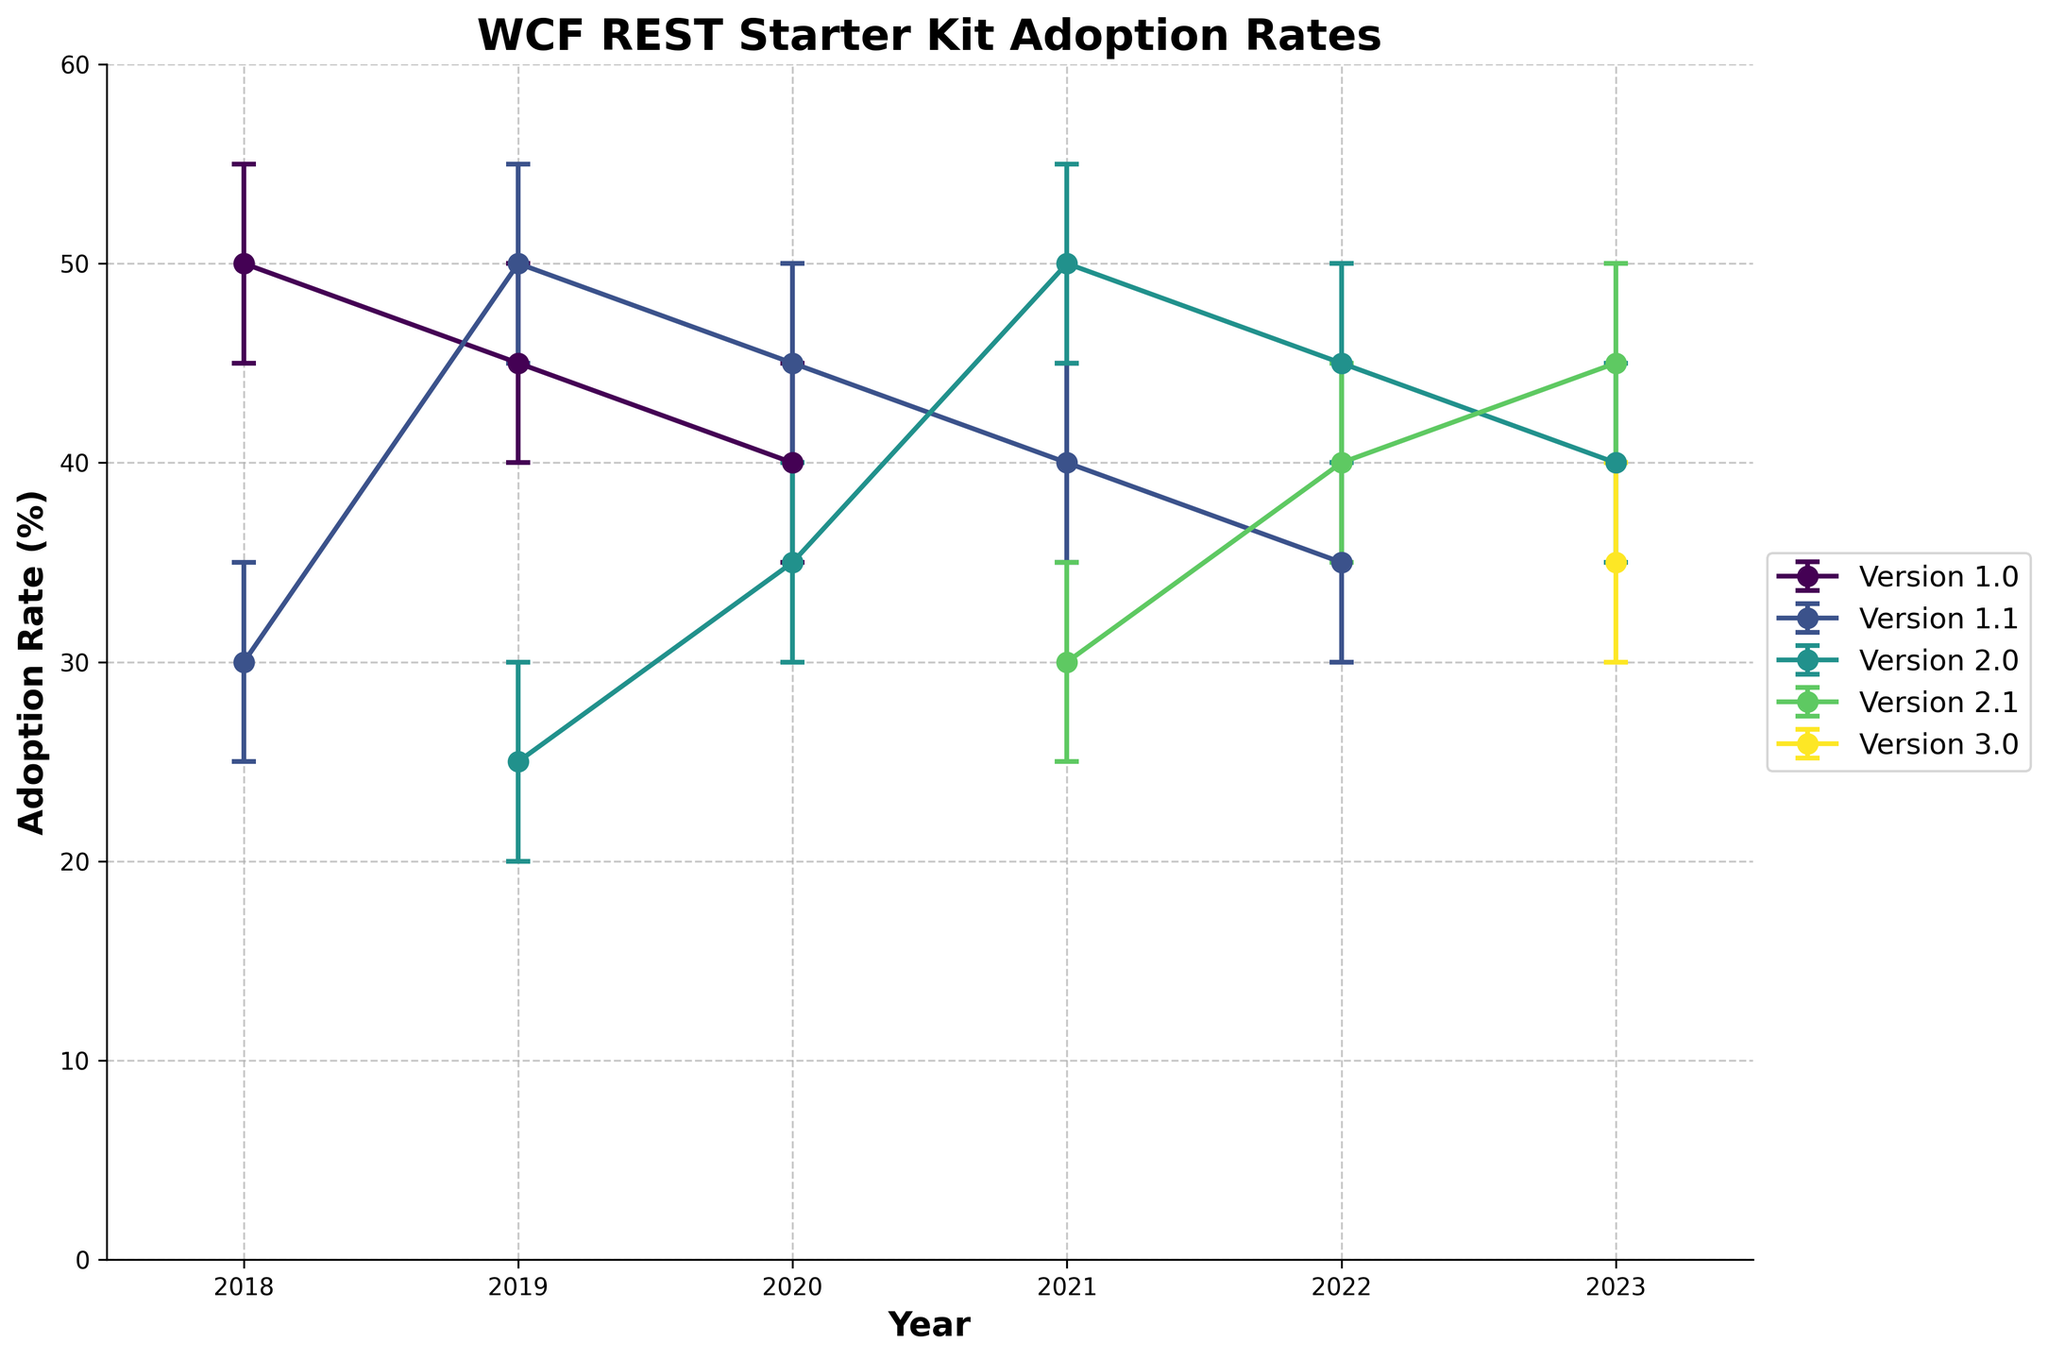How many versions of the WCF REST Starter Kit are being tracked in the figure? The different lines in the plot indicate different versions of the WCF REST Starter Kit being tracked in the figure. Each line corresponds to a unique version mentioned in the legend. There are six versions: 1.0, 1.1, 2.0, 2.1, and 3.0.
Answer: 6 Which version had the highest adoption rate in 2022? By looking at the data points for the year 2022, the highest adoption rate among all versions is observed by noting their respective y-coordinates. Version 2.0 has the highest adoption rate of 45%.
Answer: Version 2.0 Which year had the largest number of different versions tracked? The figure includes data points for different versions for each year. By counting the unique versions for each year, we see that 2019, 2020, 2021, 2022, and 2023 each have three versions. Since these are the maximum, they share the record.
Answer: 2019, 2020, 2021, 2022, & 2023 (each 3 versions) What was the adoption rate trend for version 2.0 from 2019 to 2023? The trend can be deduced by observing the y-coordinates of the data points for version 2.0 across the years. The adoption rates are as follows: 25% (2019), 35% (2020), 50% (2021), 45% (2022), and 40% (2023). This shows an initial increase to a peak in 2021, followed by a slight decrease until 2023.
Answer: Initially increasing, peaking in 2021, then decreasing Comparing versions 1.0 and 1.1, which one had a more stable adoption rate over the years? To determine stability, we look at the fluctuations in the adoption rates. Version 1.0 shows a decrease from 50% (2018) to 40% (2020), while version 1.1 fluctuates more significantly, increasing from 30% (2018) to 45% (2020) then decreasing to 35% (2022). Version 1.0 exhibits a slightly more stable trend when compared to 1.1.
Answer: Version 1.0 What is the average adoption rate of version 1.1 across all years? Calculating the average, we add the adoption rates of version 1.1 across different years: 30% (2018), 50% (2019), 45% (2020), 40% (2021), and 35% (2022) which totals 200%. Dividing by the number of years (5) gives the average: 200 / 5 = 40%.
Answer: 40% Which version recorded an adoption rate between 25% and 35% in 2023? Checking the adoption rates of different versions in 2023, we note that version 3.0 had an adoption rate of 35%, which falls within the specified range.
Answer: Version 3.0 Between 2019 and 2020, which version showed the most significant change in adoption rate? The largest change in adoption rates between 2019 and 2020 can be identified by calculating the differences. Version 2.0 changed from 25% to 35%, which is an increase of 10%. Other versions did not change as significantly.
Answer: Version 2.0 Which version has shown a consistent increase in adoption rate over the years covered in the plot? By examining the data points for each version, version 2.1 shows a consistent increase in adoption rate: 30% (2021), 40% (2022), and 45% (2023).
Answer: Version 2.1 